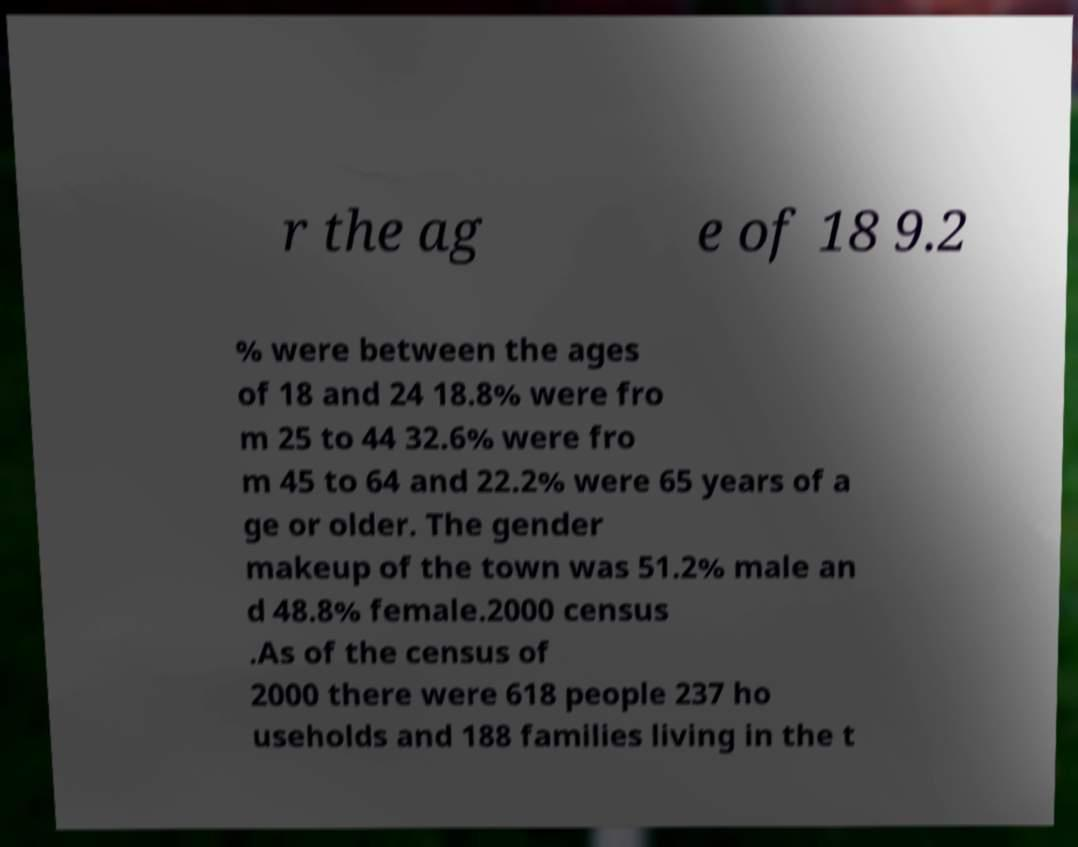Could you assist in decoding the text presented in this image and type it out clearly? r the ag e of 18 9.2 % were between the ages of 18 and 24 18.8% were fro m 25 to 44 32.6% were fro m 45 to 64 and 22.2% were 65 years of a ge or older. The gender makeup of the town was 51.2% male an d 48.8% female.2000 census .As of the census of 2000 there were 618 people 237 ho useholds and 188 families living in the t 